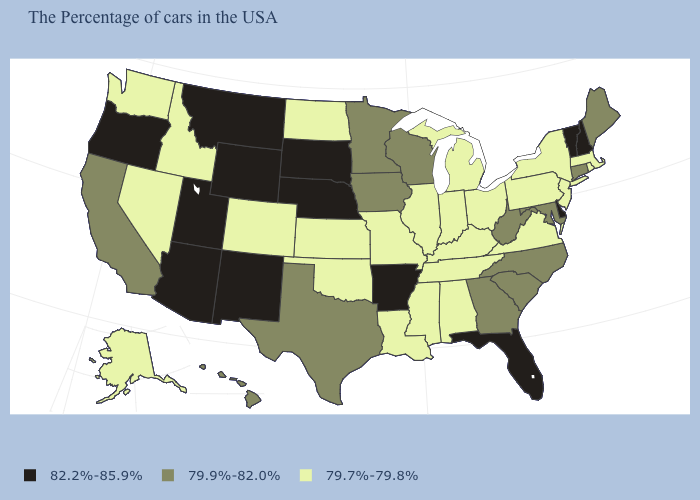Does the first symbol in the legend represent the smallest category?
Quick response, please. No. Does New Mexico have the highest value in the USA?
Short answer required. Yes. What is the highest value in the USA?
Quick response, please. 82.2%-85.9%. How many symbols are there in the legend?
Concise answer only. 3. What is the value of Mississippi?
Be succinct. 79.7%-79.8%. Name the states that have a value in the range 82.2%-85.9%?
Concise answer only. New Hampshire, Vermont, Delaware, Florida, Arkansas, Nebraska, South Dakota, Wyoming, New Mexico, Utah, Montana, Arizona, Oregon. Does the map have missing data?
Keep it brief. No. What is the value of New York?
Be succinct. 79.7%-79.8%. What is the value of New Hampshire?
Be succinct. 82.2%-85.9%. What is the value of Alabama?
Give a very brief answer. 79.7%-79.8%. Among the states that border West Virginia , which have the highest value?
Write a very short answer. Maryland. Which states have the lowest value in the USA?
Short answer required. Massachusetts, Rhode Island, New York, New Jersey, Pennsylvania, Virginia, Ohio, Michigan, Kentucky, Indiana, Alabama, Tennessee, Illinois, Mississippi, Louisiana, Missouri, Kansas, Oklahoma, North Dakota, Colorado, Idaho, Nevada, Washington, Alaska. What is the value of New Hampshire?
Write a very short answer. 82.2%-85.9%. What is the value of West Virginia?
Give a very brief answer. 79.9%-82.0%. Name the states that have a value in the range 79.7%-79.8%?
Write a very short answer. Massachusetts, Rhode Island, New York, New Jersey, Pennsylvania, Virginia, Ohio, Michigan, Kentucky, Indiana, Alabama, Tennessee, Illinois, Mississippi, Louisiana, Missouri, Kansas, Oklahoma, North Dakota, Colorado, Idaho, Nevada, Washington, Alaska. 